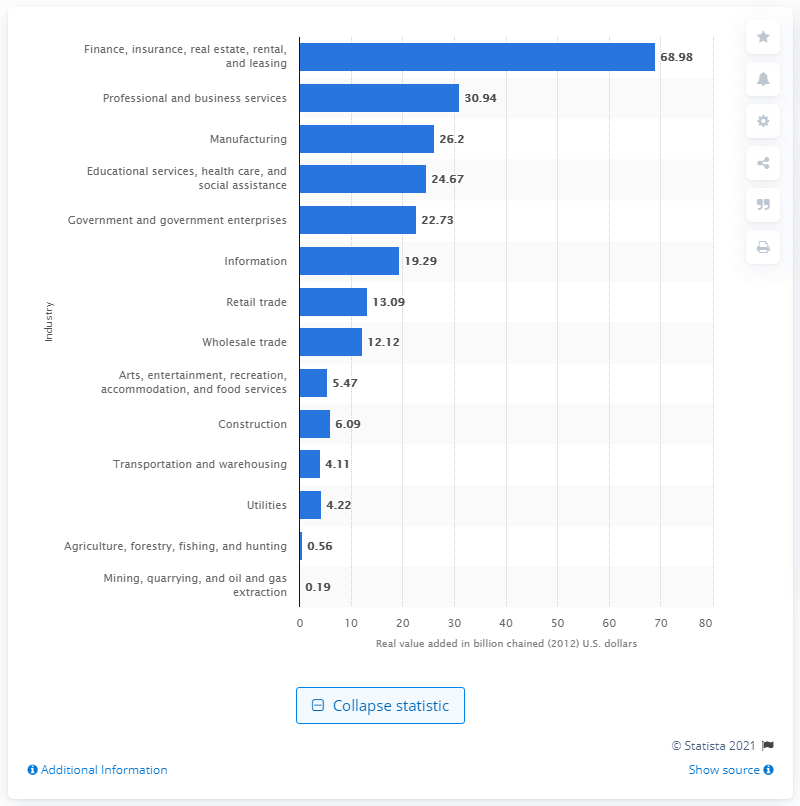Draw attention to some important aspects in this diagram. The finance, insurance, real estate, rental, and leasing industry contributed $68.98 billion to Connecticut's GDP in 2020. 